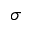<formula> <loc_0><loc_0><loc_500><loc_500>\sigma</formula> 